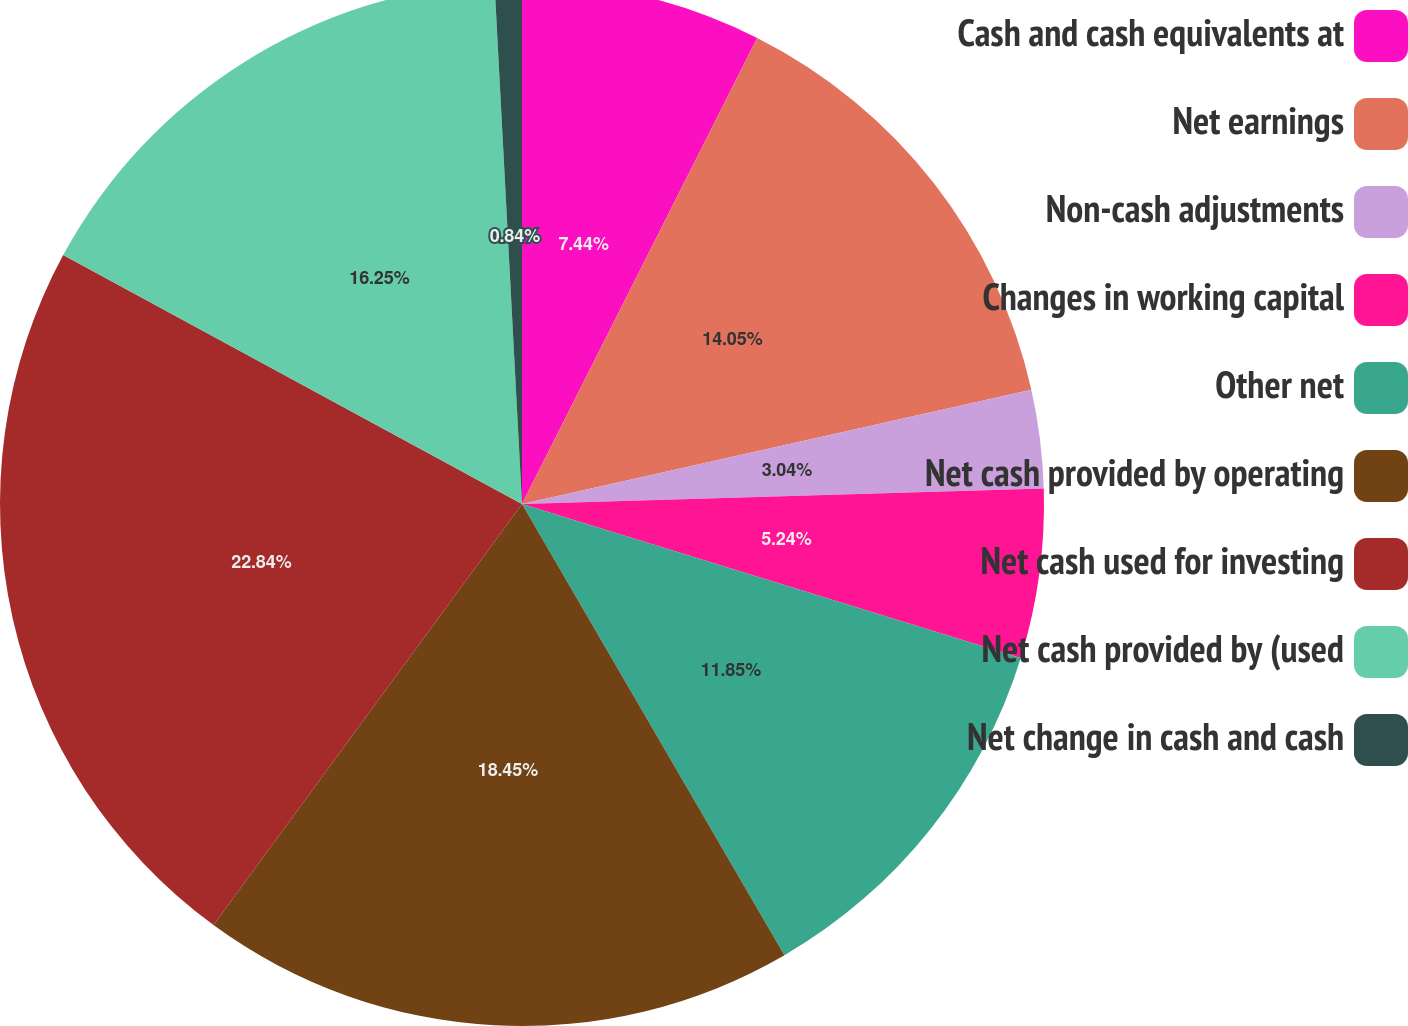<chart> <loc_0><loc_0><loc_500><loc_500><pie_chart><fcel>Cash and cash equivalents at<fcel>Net earnings<fcel>Non-cash adjustments<fcel>Changes in working capital<fcel>Other net<fcel>Net cash provided by operating<fcel>Net cash used for investing<fcel>Net cash provided by (used<fcel>Net change in cash and cash<nl><fcel>7.44%<fcel>14.05%<fcel>3.04%<fcel>5.24%<fcel>11.85%<fcel>18.45%<fcel>22.85%<fcel>16.25%<fcel>0.84%<nl></chart> 